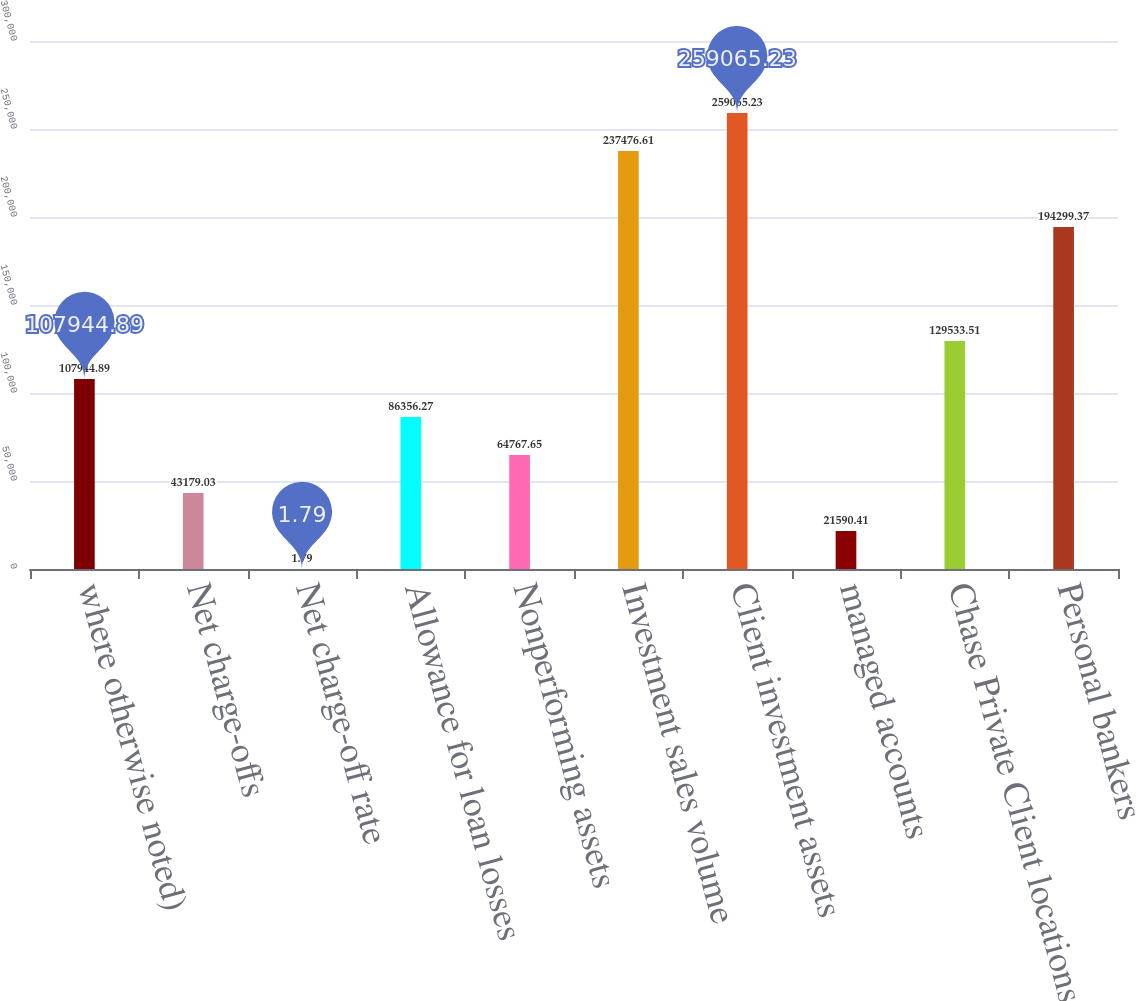Convert chart. <chart><loc_0><loc_0><loc_500><loc_500><bar_chart><fcel>where otherwise noted)<fcel>Net charge-offs<fcel>Net charge-off rate<fcel>Allowance for loan losses<fcel>Nonperforming assets<fcel>Investment sales volume<fcel>Client investment assets<fcel>managed accounts<fcel>Chase Private Client locations<fcel>Personal bankers<nl><fcel>107945<fcel>43179<fcel>1.79<fcel>86356.3<fcel>64767.7<fcel>237477<fcel>259065<fcel>21590.4<fcel>129534<fcel>194299<nl></chart> 